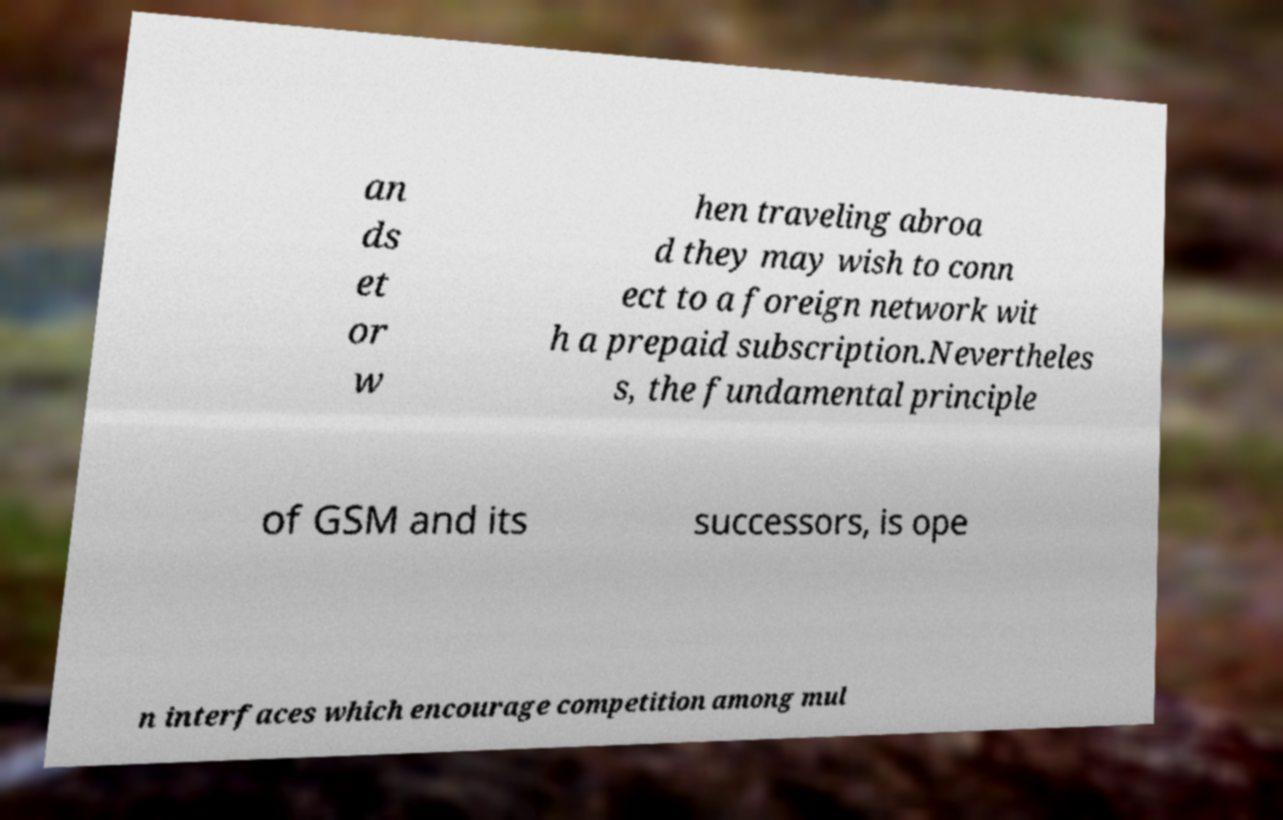Can you read and provide the text displayed in the image?This photo seems to have some interesting text. Can you extract and type it out for me? an ds et or w hen traveling abroa d they may wish to conn ect to a foreign network wit h a prepaid subscription.Nevertheles s, the fundamental principle of GSM and its successors, is ope n interfaces which encourage competition among mul 